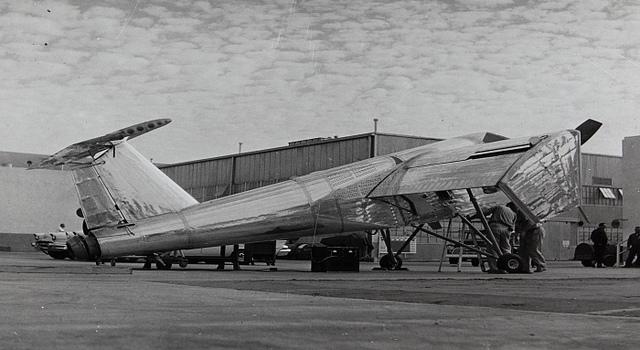Who is the polite?
Give a very brief answer. Mechanic. What is on the tarmac?
Give a very brief answer. Airplane. What kind of aircraft is there?
Write a very short answer. Airplane. 